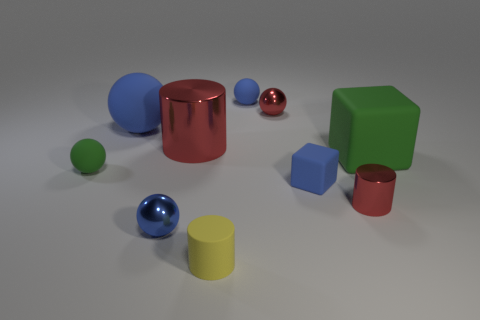What number of small objects are either blue shiny spheres or green objects?
Make the answer very short. 2. What number of objects are either cylinders that are to the right of the yellow rubber cylinder or red metal cylinders that are in front of the tiny green matte thing?
Provide a succinct answer. 1. Is the number of blue things less than the number of small green metallic spheres?
Your answer should be very brief. No. There is a green rubber object that is the same size as the matte cylinder; what is its shape?
Ensure brevity in your answer.  Sphere. What number of other objects are the same color as the small rubber block?
Provide a succinct answer. 3. How many green matte things are there?
Your response must be concise. 2. What number of things are both to the left of the big matte sphere and right of the green ball?
Your response must be concise. 0. What material is the large red cylinder?
Your answer should be compact. Metal. Are there any purple metallic blocks?
Make the answer very short. No. The small rubber object that is behind the small green rubber thing is what color?
Keep it short and to the point. Blue. 